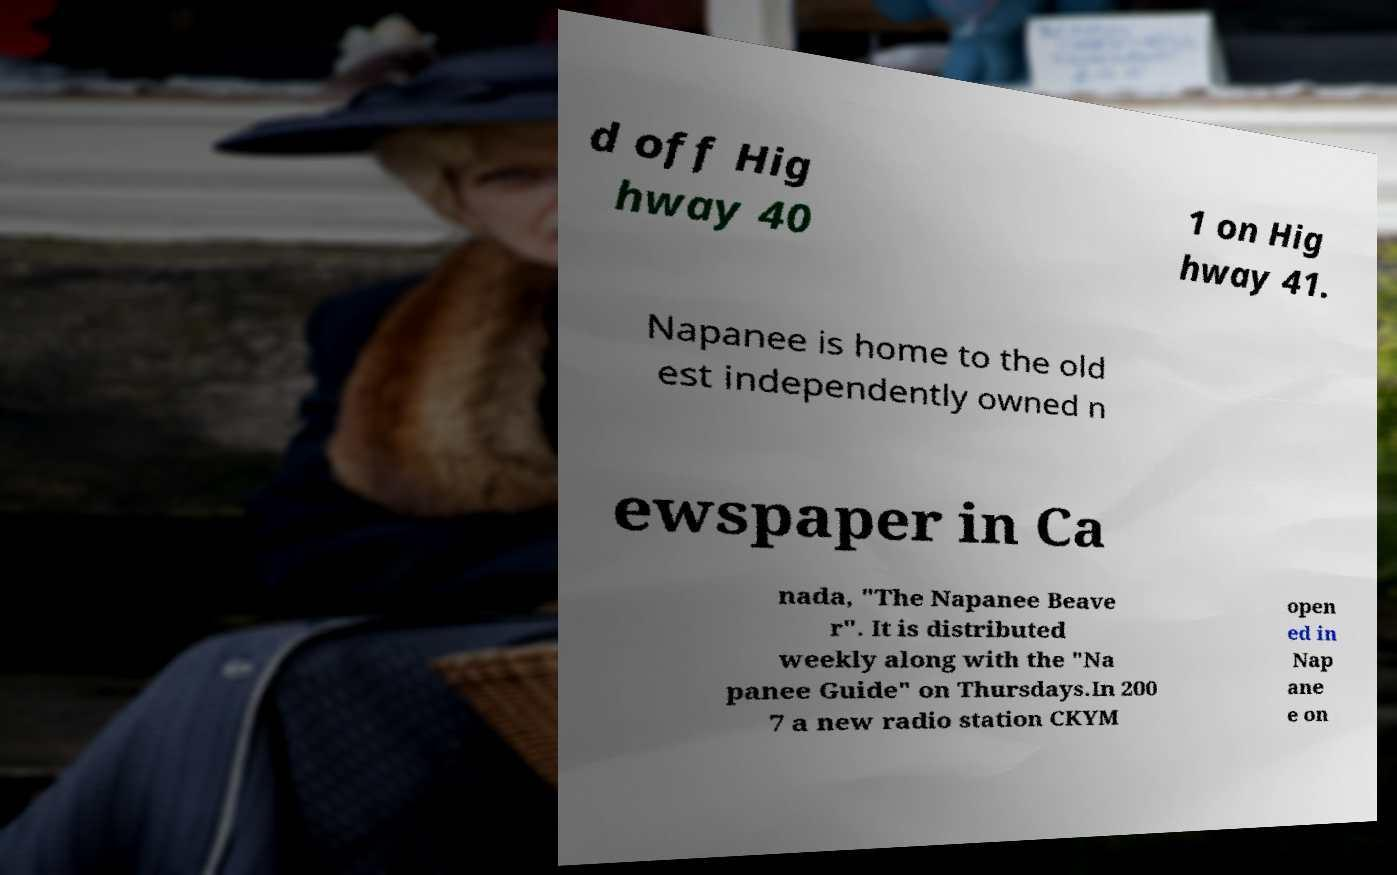Could you extract and type out the text from this image? d off Hig hway 40 1 on Hig hway 41. Napanee is home to the old est independently owned n ewspaper in Ca nada, "The Napanee Beave r". It is distributed weekly along with the "Na panee Guide" on Thursdays.In 200 7 a new radio station CKYM open ed in Nap ane e on 